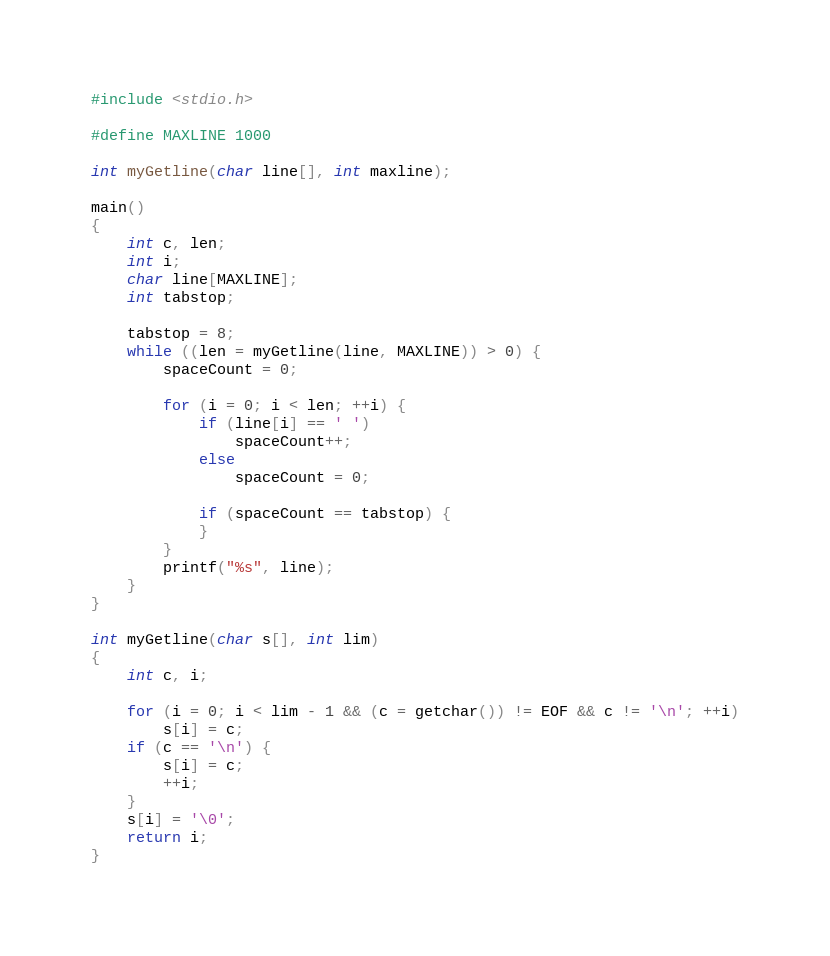<code> <loc_0><loc_0><loc_500><loc_500><_C_>#include <stdio.h>

#define MAXLINE 1000

int myGetline(char line[], int maxline);

main()
{
	int c, len;
	int i;
	char line[MAXLINE];
	int tabstop;

	tabstop = 8;
	while ((len = myGetline(line, MAXLINE)) > 0) {
		spaceCount = 0;

		for (i = 0; i < len; ++i) {
			if (line[i] == ' ')
				spaceCount++;
			else
				spaceCount = 0;

			if (spaceCount == tabstop) {
			}
		}
		printf("%s", line);
	}
}

int myGetline(char s[], int lim)
{
	int c, i;

	for (i = 0; i < lim - 1 && (c = getchar()) != EOF && c != '\n'; ++i)
		s[i] = c;
	if (c == '\n') {
		s[i] = c;
		++i;
	}
	s[i] = '\0';
	return i;
}
</code> 